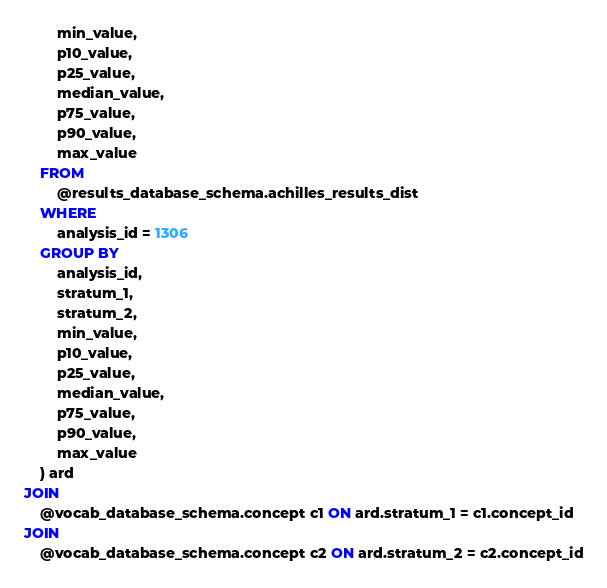Convert code to text. <code><loc_0><loc_0><loc_500><loc_500><_SQL_>		min_value,
		p10_value,
		p25_value,
		median_value,
		p75_value,
		p90_value,
		max_value
	FROM 
		@results_database_schema.achilles_results_dist
	WHERE 
		analysis_id = 1306
	GROUP BY 
		analysis_id,
		stratum_1,
		stratum_2,
		min_value,
		p10_value,
		p25_value,
		median_value,
		p75_value,
		p90_value,
		max_value
	) ard
JOIN 
	@vocab_database_schema.concept c1 ON ard.stratum_1 = c1.concept_id
JOIN 
	@vocab_database_schema.concept c2 ON ard.stratum_2 = c2.concept_id
</code> 